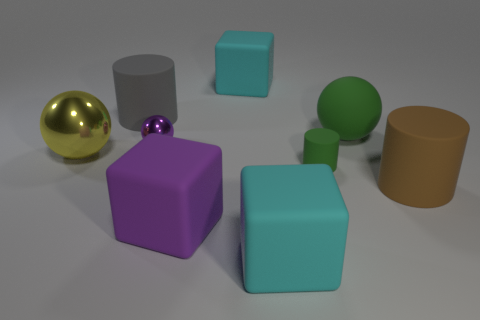Subtract all cubes. How many objects are left? 6 Add 7 large gray shiny cubes. How many large gray shiny cubes exist? 7 Subtract 0 brown blocks. How many objects are left? 9 Subtract all big blocks. Subtract all large purple shiny things. How many objects are left? 6 Add 2 big brown cylinders. How many big brown cylinders are left? 3 